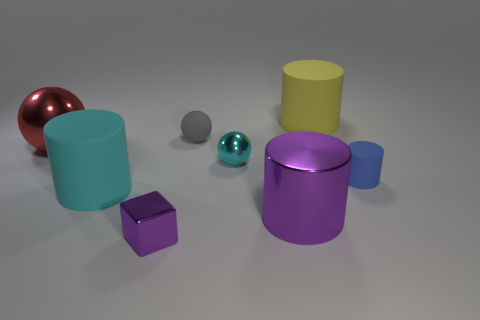Are there the same number of objects in front of the gray thing and gray rubber things?
Your answer should be compact. No. There is a large purple metal cylinder that is in front of the small matte object that is left of the tiny cylinder; how many blue matte cylinders are on the right side of it?
Make the answer very short. 1. Is there a cyan matte cylinder that has the same size as the red metallic thing?
Give a very brief answer. Yes. Are there fewer cyan things that are behind the cyan cylinder than yellow cylinders?
Give a very brief answer. No. The purple cylinder that is on the right side of the small metal object that is behind the large shiny object that is in front of the tiny cyan ball is made of what material?
Make the answer very short. Metal. Are there more red metal objects right of the large yellow thing than cubes to the right of the small gray ball?
Make the answer very short. No. What number of shiny things are tiny gray balls or cyan cylinders?
Give a very brief answer. 0. There is a large metallic thing that is the same color as the tiny metallic block; what shape is it?
Your response must be concise. Cylinder. There is a purple thing that is to the right of the tiny cyan metallic ball; what material is it?
Ensure brevity in your answer.  Metal. How many things are either large gray objects or purple metallic things behind the purple shiny cube?
Make the answer very short. 1. 